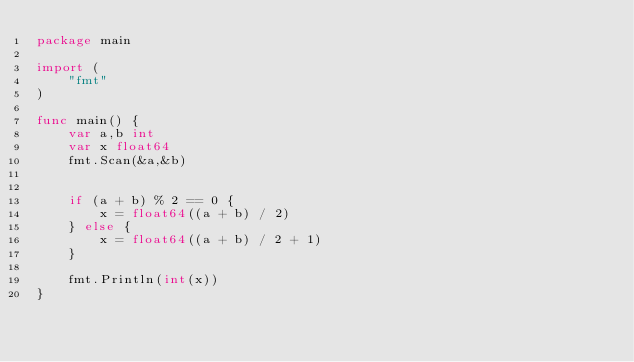<code> <loc_0><loc_0><loc_500><loc_500><_Go_>package main

import (
	"fmt"
)

func main() {
	var a,b int
	var x float64
	fmt.Scan(&a,&b)
	
	
	if (a + b) % 2 == 0 {
		x = float64((a + b) / 2)
	} else {
		x = float64((a + b) / 2 + 1)
	}
	
	fmt.Println(int(x))
}</code> 